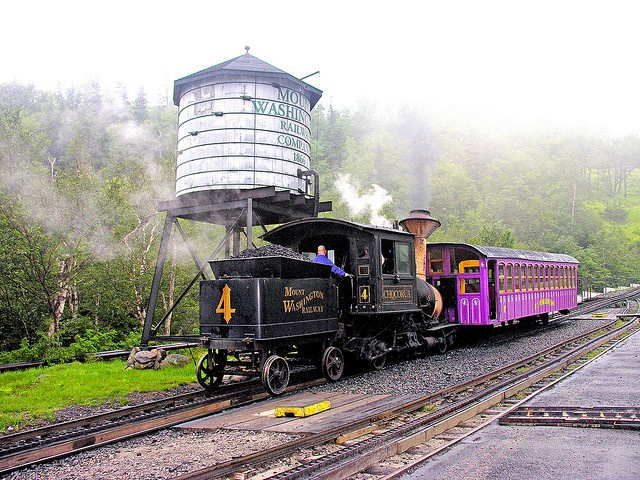Describe the objects in this image and their specific colors. I can see train in white, black, gray, darkgray, and purple tones and people in white, blue, lightpink, and magenta tones in this image. 